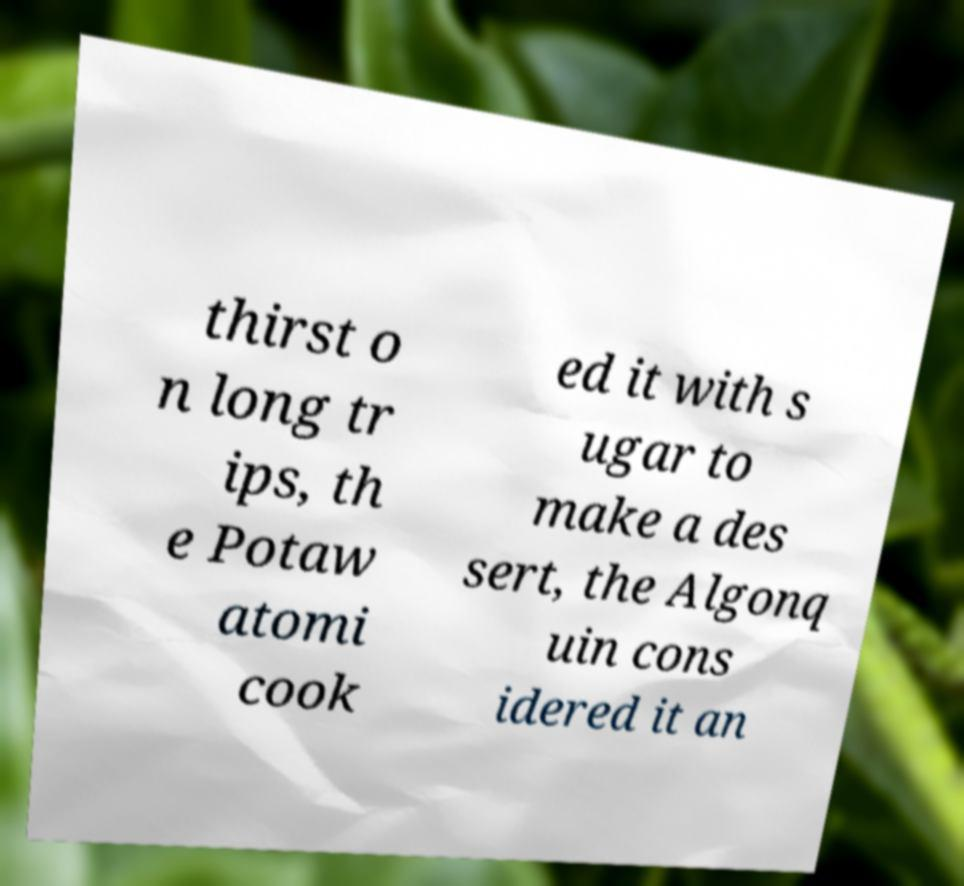What messages or text are displayed in this image? I need them in a readable, typed format. thirst o n long tr ips, th e Potaw atomi cook ed it with s ugar to make a des sert, the Algonq uin cons idered it an 